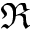Convert formula to latex. <formula><loc_0><loc_0><loc_500><loc_500>\Re</formula> 